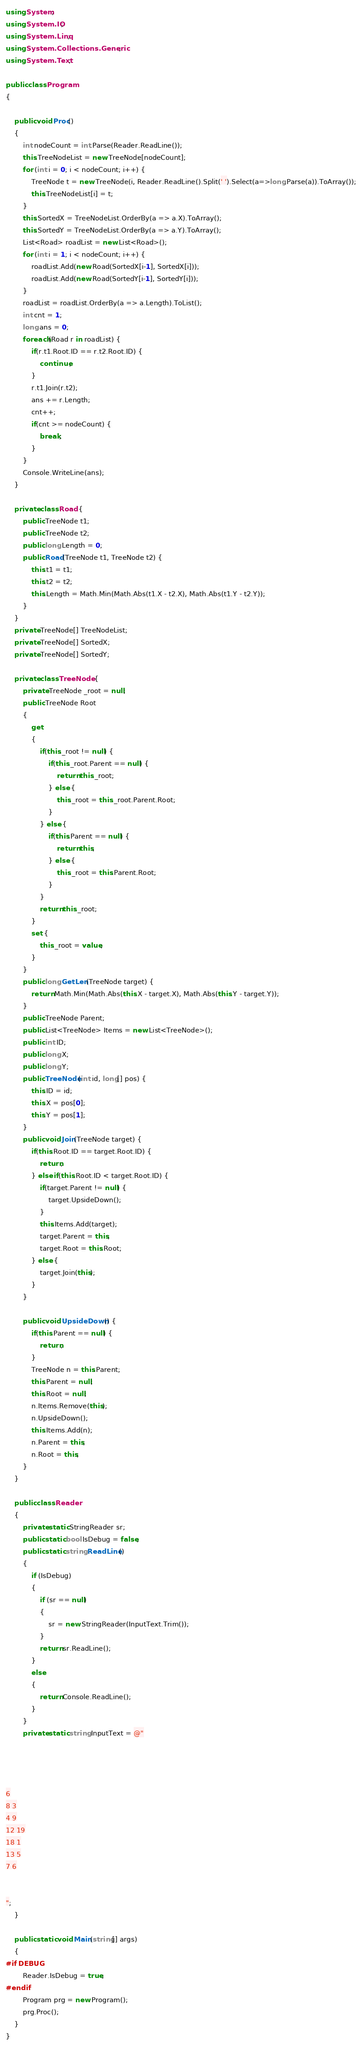<code> <loc_0><loc_0><loc_500><loc_500><_C#_>using System;
using System.IO;
using System.Linq;
using System.Collections.Generic;
using System.Text;

public class Program
{

    public void Proc()
    {
        int nodeCount = int.Parse(Reader.ReadLine());
        this.TreeNodeList = new TreeNode[nodeCount];
        for (int i = 0; i < nodeCount; i++) {
            TreeNode t = new TreeNode(i, Reader.ReadLine().Split(' ').Select(a=>long.Parse(a)).ToArray());
            this.TreeNodeList[i] = t;
        }
        this.SortedX = TreeNodeList.OrderBy(a => a.X).ToArray();
        this.SortedY = TreeNodeList.OrderBy(a => a.Y).ToArray();
        List<Road> roadList = new List<Road>();
        for (int i = 1; i < nodeCount; i++) {
            roadList.Add(new Road(SortedX[i-1], SortedX[i]));
            roadList.Add(new Road(SortedY[i-1], SortedY[i]));
        }
        roadList = roadList.OrderBy(a => a.Length).ToList();
        int cnt = 1;
        long ans = 0;
        foreach(Road r in roadList) {
            if(r.t1.Root.ID == r.t2.Root.ID) {
                continue;
            }
            r.t1.Join(r.t2);
            ans += r.Length;
            cnt++;
            if(cnt >= nodeCount) {
                break;
            }
        }
        Console.WriteLine(ans);
	}

    private class Road {
        public TreeNode t1;
        public TreeNode t2;
        public long Length = 0;
        public Road(TreeNode t1, TreeNode t2) {
            this.t1 = t1;
            this.t2 = t2;
            this.Length = Math.Min(Math.Abs(t1.X - t2.X), Math.Abs(t1.Y - t2.Y));
        }
    }
    private TreeNode[] TreeNodeList;
    private TreeNode[] SortedX;
    private TreeNode[] SortedY;

    private class TreeNode {
		private TreeNode _root = null;
		public TreeNode Root
		{
			get
			{
                if(this._root != null) {
                    if(this._root.Parent == null) {
                        return this._root;
                    } else {
                        this._root = this._root.Parent.Root;
                    }
                } else {
                    if(this.Parent == null) {
                        return this;
                    } else {
                        this._root = this.Parent.Root;
                    }
                }
                return this._root;
			}
            set {
                this._root = value;
            }
		}
		public long GetLen(TreeNode target) {
            return Math.Min(Math.Abs(this.X - target.X), Math.Abs(this.Y - target.Y));
        }
        public TreeNode Parent;
        public List<TreeNode> Items = new List<TreeNode>();
        public int ID;
        public long X;
        public long Y;
        public TreeNode(int id, long[] pos) {
            this.ID = id;
            this.X = pos[0];
            this.Y = pos[1];
        }
        public void Join(TreeNode target) {
            if(this.Root.ID == target.Root.ID) {
                return; 
            } else if(this.Root.ID < target.Root.ID) {
                if(target.Parent != null) {
                    target.UpsideDown();
                }
				this.Items.Add(target);
				target.Parent = this;
				target.Root = this.Root;
			} else {
                target.Join(this);
            }
        }

        public void UpsideDown() {
            if(this.Parent == null) {
                return;
            }
            TreeNode n = this.Parent;
            this.Parent = null;
            this.Root = null;
            n.Items.Remove(this);
            n.UpsideDown();
            this.Items.Add(n);
            n.Parent = this;
            n.Root = this;
        }
    }

    public class Reader
	{
		private static StringReader sr;
		public static bool IsDebug = false;
		public static string ReadLine()
		{
			if (IsDebug)
			{
				if (sr == null)
				{
					sr = new StringReader(InputText.Trim());
				}
				return sr.ReadLine();
			}
			else
			{
				return Console.ReadLine();
			}
		}
		private static string InputText = @"




6
8 3
4 9
12 19
18 1
13 5
7 6


";
	}

	public static void Main(string[] args)
	{
#if DEBUG
		Reader.IsDebug = true;
#endif
		Program prg = new Program();
		prg.Proc();
	}
}
</code> 